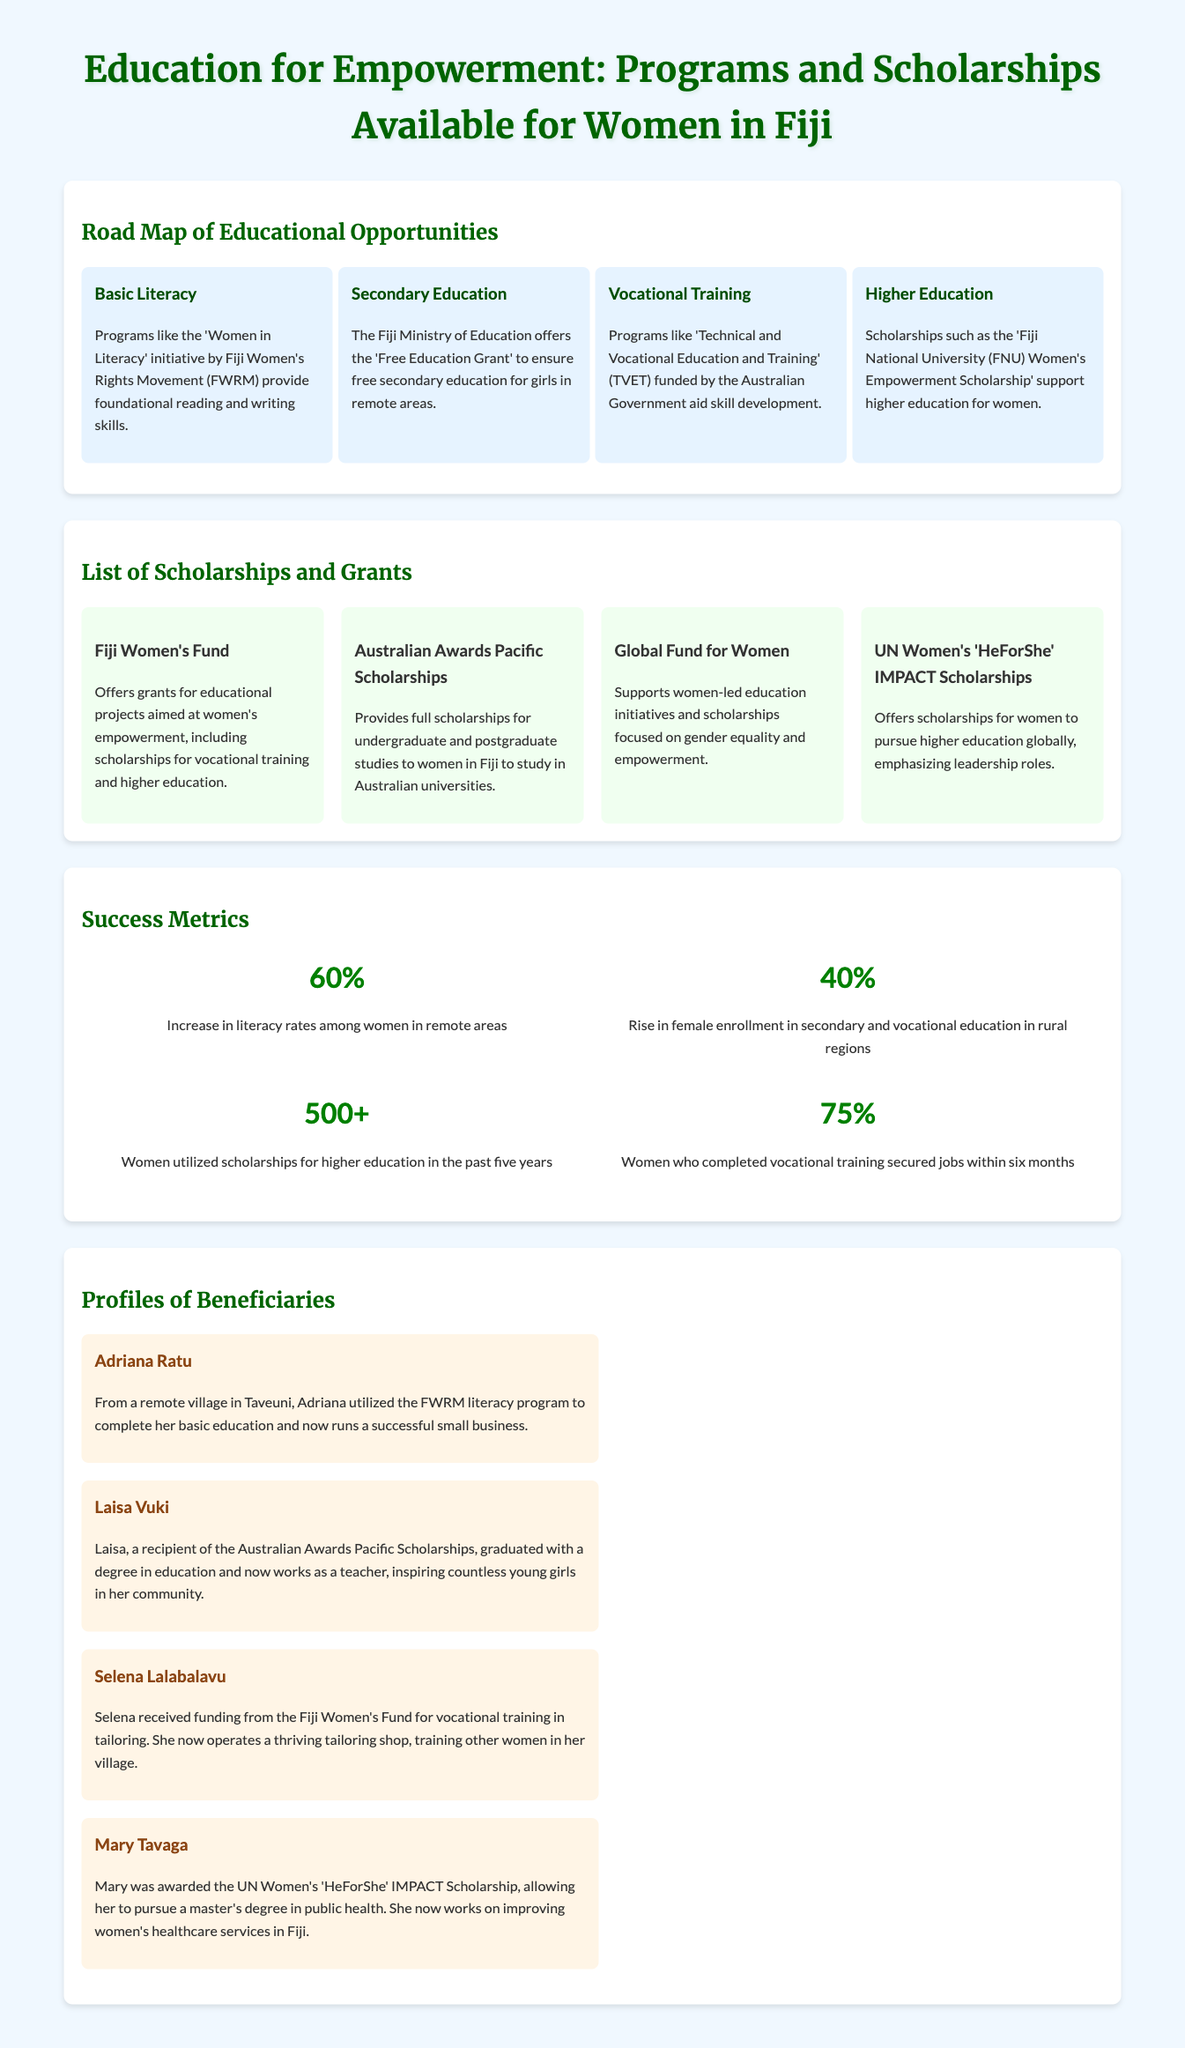what program provides foundational reading and writing skills? The 'Women in Literacy' initiative by Fiji Women's Rights Movement (FWRM) offers foundational reading and writing skills.
Answer: Women in Literacy what percentage of women completed vocational training secured jobs within six months? The document states that 75% of women who completed vocational training secured jobs within six months.
Answer: 75% which scholarship is focused on women's empowerment and higher education? The 'Fiji National University (FNU) Women's Empowerment Scholarship' is focused on women's empowerment and higher education.
Answer: FNU Women's Empowerment Scholarship how many women utilized scholarships for higher education in the past five years? The document indicates that 500+ women utilized scholarships for higher education in the past five years.
Answer: 500+ what is the increase in literacy rates among women in remote areas? The increase in literacy rates among women in remote areas is reported as 60%.
Answer: 60% who is a beneficiary of the Australian Awards Pacific Scholarships? Laisa Vuki is a beneficiary of the Australian Awards Pacific Scholarships.
Answer: Laisa Vuki which scholarship supports women-led education initiatives? The Global Fund for Women supports women-led education initiatives and scholarships focused on gender equality and empowerment.
Answer: Global Fund for Women what type of education does the Fiji Ministry of Education support for girls in remote areas? The Fiji Ministry of Education offers the 'Free Education Grant' to ensure free secondary education for girls in remote areas.
Answer: Free Education Grant who runs a successful small business after completing the basic education program? Adriana Ratu runs a successful small business after completing the basic education program.
Answer: Adriana Ratu 